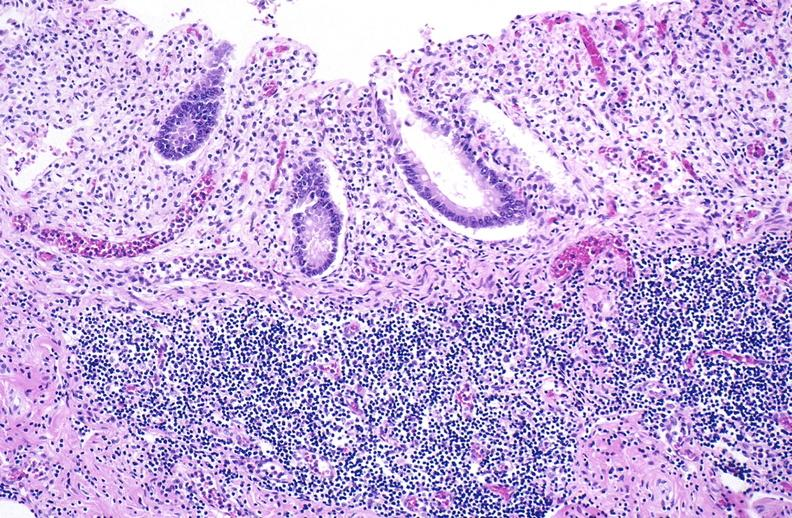does this image show normal appendix?
Answer the question using a single word or phrase. Yes 